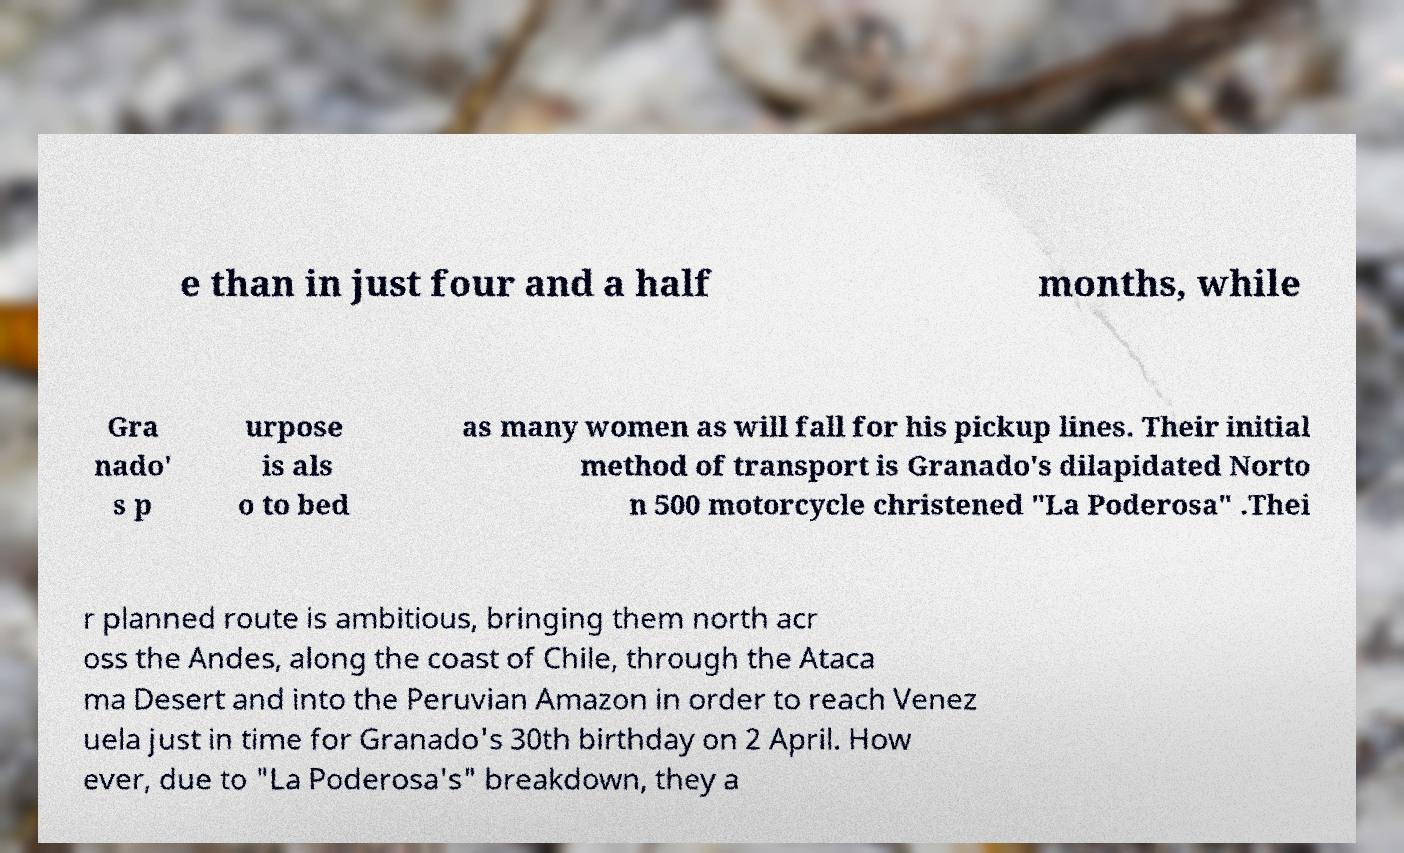Can you accurately transcribe the text from the provided image for me? e than in just four and a half months, while Gra nado' s p urpose is als o to bed as many women as will fall for his pickup lines. Their initial method of transport is Granado's dilapidated Norto n 500 motorcycle christened "La Poderosa" .Thei r planned route is ambitious, bringing them north acr oss the Andes, along the coast of Chile, through the Ataca ma Desert and into the Peruvian Amazon in order to reach Venez uela just in time for Granado's 30th birthday on 2 April. How ever, due to "La Poderosa's" breakdown, they a 